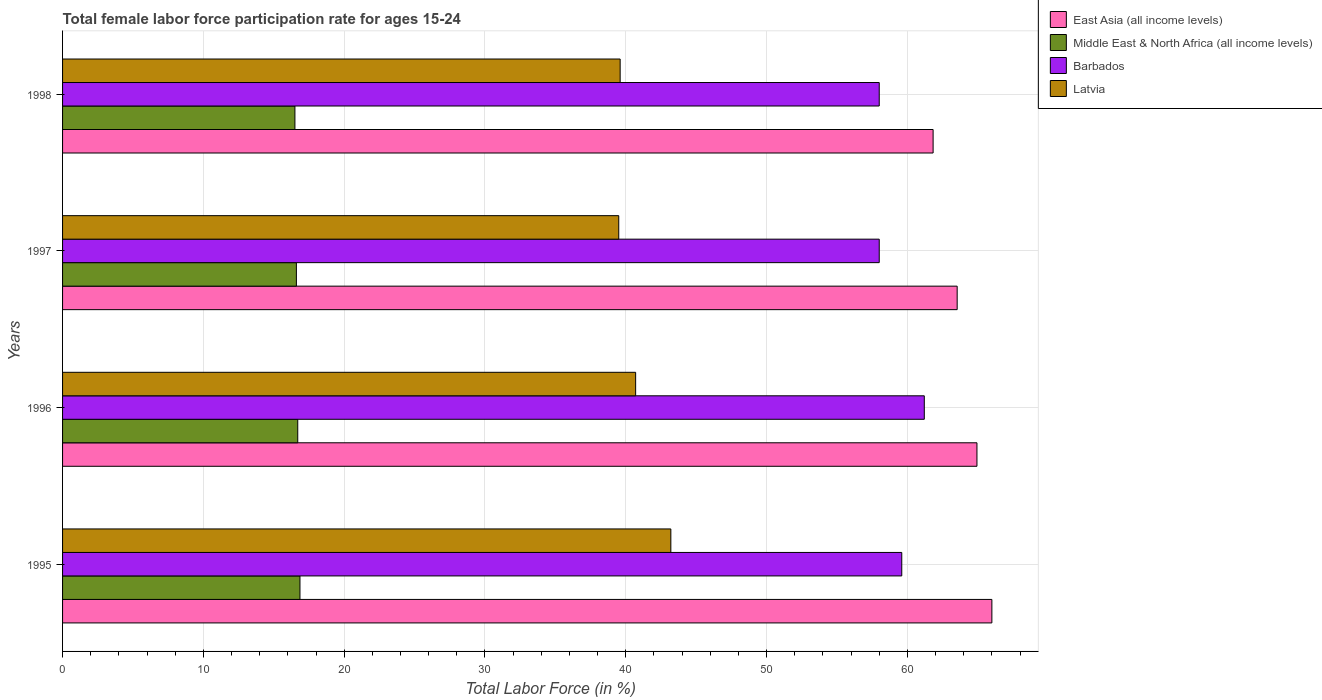How many different coloured bars are there?
Your response must be concise. 4. How many bars are there on the 1st tick from the top?
Provide a succinct answer. 4. What is the label of the 1st group of bars from the top?
Provide a succinct answer. 1998. In how many cases, is the number of bars for a given year not equal to the number of legend labels?
Your answer should be compact. 0. What is the female labor force participation rate in Middle East & North Africa (all income levels) in 1997?
Provide a succinct answer. 16.61. Across all years, what is the maximum female labor force participation rate in East Asia (all income levels)?
Keep it short and to the point. 66. Across all years, what is the minimum female labor force participation rate in Middle East & North Africa (all income levels)?
Provide a succinct answer. 16.5. In which year was the female labor force participation rate in Middle East & North Africa (all income levels) maximum?
Provide a short and direct response. 1995. What is the total female labor force participation rate in East Asia (all income levels) in the graph?
Give a very brief answer. 256.3. What is the difference between the female labor force participation rate in Middle East & North Africa (all income levels) in 1995 and that in 1997?
Ensure brevity in your answer.  0.25. What is the difference between the female labor force participation rate in Latvia in 1996 and the female labor force participation rate in Barbados in 1998?
Provide a short and direct response. -17.3. What is the average female labor force participation rate in East Asia (all income levels) per year?
Your answer should be compact. 64.07. In the year 1995, what is the difference between the female labor force participation rate in Middle East & North Africa (all income levels) and female labor force participation rate in Barbados?
Offer a very short reply. -42.74. What is the ratio of the female labor force participation rate in Latvia in 1996 to that in 1997?
Keep it short and to the point. 1.03. Is the difference between the female labor force participation rate in Middle East & North Africa (all income levels) in 1996 and 1997 greater than the difference between the female labor force participation rate in Barbados in 1996 and 1997?
Your response must be concise. No. What is the difference between the highest and the second highest female labor force participation rate in Middle East & North Africa (all income levels)?
Your answer should be very brief. 0.16. What is the difference between the highest and the lowest female labor force participation rate in Latvia?
Keep it short and to the point. 3.7. In how many years, is the female labor force participation rate in Middle East & North Africa (all income levels) greater than the average female labor force participation rate in Middle East & North Africa (all income levels) taken over all years?
Your response must be concise. 2. Is the sum of the female labor force participation rate in Latvia in 1995 and 1996 greater than the maximum female labor force participation rate in East Asia (all income levels) across all years?
Your response must be concise. Yes. Is it the case that in every year, the sum of the female labor force participation rate in Barbados and female labor force participation rate in Middle East & North Africa (all income levels) is greater than the sum of female labor force participation rate in East Asia (all income levels) and female labor force participation rate in Latvia?
Your response must be concise. No. What does the 1st bar from the top in 1997 represents?
Your answer should be compact. Latvia. What does the 2nd bar from the bottom in 1996 represents?
Offer a terse response. Middle East & North Africa (all income levels). Is it the case that in every year, the sum of the female labor force participation rate in Latvia and female labor force participation rate in East Asia (all income levels) is greater than the female labor force participation rate in Barbados?
Ensure brevity in your answer.  Yes. How many years are there in the graph?
Keep it short and to the point. 4. Are the values on the major ticks of X-axis written in scientific E-notation?
Keep it short and to the point. No. Where does the legend appear in the graph?
Your answer should be compact. Top right. What is the title of the graph?
Give a very brief answer. Total female labor force participation rate for ages 15-24. Does "El Salvador" appear as one of the legend labels in the graph?
Keep it short and to the point. No. What is the label or title of the X-axis?
Offer a very short reply. Total Labor Force (in %). What is the Total Labor Force (in %) of East Asia (all income levels) in 1995?
Your answer should be compact. 66. What is the Total Labor Force (in %) in Middle East & North Africa (all income levels) in 1995?
Your answer should be very brief. 16.86. What is the Total Labor Force (in %) of Barbados in 1995?
Your answer should be very brief. 59.6. What is the Total Labor Force (in %) of Latvia in 1995?
Your answer should be very brief. 43.2. What is the Total Labor Force (in %) of East Asia (all income levels) in 1996?
Offer a terse response. 64.94. What is the Total Labor Force (in %) in Middle East & North Africa (all income levels) in 1996?
Provide a succinct answer. 16.7. What is the Total Labor Force (in %) in Barbados in 1996?
Your answer should be compact. 61.2. What is the Total Labor Force (in %) in Latvia in 1996?
Provide a short and direct response. 40.7. What is the Total Labor Force (in %) of East Asia (all income levels) in 1997?
Your answer should be compact. 63.53. What is the Total Labor Force (in %) of Middle East & North Africa (all income levels) in 1997?
Give a very brief answer. 16.61. What is the Total Labor Force (in %) of Latvia in 1997?
Provide a succinct answer. 39.5. What is the Total Labor Force (in %) in East Asia (all income levels) in 1998?
Offer a terse response. 61.83. What is the Total Labor Force (in %) of Middle East & North Africa (all income levels) in 1998?
Ensure brevity in your answer.  16.5. What is the Total Labor Force (in %) of Barbados in 1998?
Offer a very short reply. 58. What is the Total Labor Force (in %) in Latvia in 1998?
Give a very brief answer. 39.6. Across all years, what is the maximum Total Labor Force (in %) of East Asia (all income levels)?
Ensure brevity in your answer.  66. Across all years, what is the maximum Total Labor Force (in %) in Middle East & North Africa (all income levels)?
Ensure brevity in your answer.  16.86. Across all years, what is the maximum Total Labor Force (in %) in Barbados?
Keep it short and to the point. 61.2. Across all years, what is the maximum Total Labor Force (in %) of Latvia?
Provide a short and direct response. 43.2. Across all years, what is the minimum Total Labor Force (in %) of East Asia (all income levels)?
Your answer should be very brief. 61.83. Across all years, what is the minimum Total Labor Force (in %) of Middle East & North Africa (all income levels)?
Provide a succinct answer. 16.5. Across all years, what is the minimum Total Labor Force (in %) of Latvia?
Your response must be concise. 39.5. What is the total Total Labor Force (in %) of East Asia (all income levels) in the graph?
Offer a terse response. 256.3. What is the total Total Labor Force (in %) in Middle East & North Africa (all income levels) in the graph?
Offer a very short reply. 66.67. What is the total Total Labor Force (in %) of Barbados in the graph?
Provide a succinct answer. 236.8. What is the total Total Labor Force (in %) in Latvia in the graph?
Your answer should be very brief. 163. What is the difference between the Total Labor Force (in %) of East Asia (all income levels) in 1995 and that in 1996?
Make the answer very short. 1.06. What is the difference between the Total Labor Force (in %) in Middle East & North Africa (all income levels) in 1995 and that in 1996?
Offer a very short reply. 0.16. What is the difference between the Total Labor Force (in %) of Barbados in 1995 and that in 1996?
Provide a short and direct response. -1.6. What is the difference between the Total Labor Force (in %) in Latvia in 1995 and that in 1996?
Offer a very short reply. 2.5. What is the difference between the Total Labor Force (in %) in East Asia (all income levels) in 1995 and that in 1997?
Make the answer very short. 2.46. What is the difference between the Total Labor Force (in %) in Middle East & North Africa (all income levels) in 1995 and that in 1997?
Ensure brevity in your answer.  0.25. What is the difference between the Total Labor Force (in %) in Barbados in 1995 and that in 1997?
Keep it short and to the point. 1.6. What is the difference between the Total Labor Force (in %) in Latvia in 1995 and that in 1997?
Provide a succinct answer. 3.7. What is the difference between the Total Labor Force (in %) in East Asia (all income levels) in 1995 and that in 1998?
Ensure brevity in your answer.  4.17. What is the difference between the Total Labor Force (in %) of Middle East & North Africa (all income levels) in 1995 and that in 1998?
Provide a short and direct response. 0.36. What is the difference between the Total Labor Force (in %) in Barbados in 1995 and that in 1998?
Offer a terse response. 1.6. What is the difference between the Total Labor Force (in %) of Latvia in 1995 and that in 1998?
Your response must be concise. 3.6. What is the difference between the Total Labor Force (in %) of East Asia (all income levels) in 1996 and that in 1997?
Keep it short and to the point. 1.41. What is the difference between the Total Labor Force (in %) in Middle East & North Africa (all income levels) in 1996 and that in 1997?
Ensure brevity in your answer.  0.1. What is the difference between the Total Labor Force (in %) of Barbados in 1996 and that in 1997?
Provide a succinct answer. 3.2. What is the difference between the Total Labor Force (in %) of Latvia in 1996 and that in 1997?
Your answer should be very brief. 1.2. What is the difference between the Total Labor Force (in %) in East Asia (all income levels) in 1996 and that in 1998?
Offer a terse response. 3.11. What is the difference between the Total Labor Force (in %) in Middle East & North Africa (all income levels) in 1996 and that in 1998?
Provide a succinct answer. 0.2. What is the difference between the Total Labor Force (in %) of Barbados in 1996 and that in 1998?
Offer a very short reply. 3.2. What is the difference between the Total Labor Force (in %) of Latvia in 1996 and that in 1998?
Offer a very short reply. 1.1. What is the difference between the Total Labor Force (in %) of East Asia (all income levels) in 1997 and that in 1998?
Your answer should be compact. 1.71. What is the difference between the Total Labor Force (in %) of Middle East & North Africa (all income levels) in 1997 and that in 1998?
Make the answer very short. 0.1. What is the difference between the Total Labor Force (in %) of Latvia in 1997 and that in 1998?
Your answer should be compact. -0.1. What is the difference between the Total Labor Force (in %) of East Asia (all income levels) in 1995 and the Total Labor Force (in %) of Middle East & North Africa (all income levels) in 1996?
Your answer should be very brief. 49.3. What is the difference between the Total Labor Force (in %) of East Asia (all income levels) in 1995 and the Total Labor Force (in %) of Barbados in 1996?
Your answer should be compact. 4.8. What is the difference between the Total Labor Force (in %) in East Asia (all income levels) in 1995 and the Total Labor Force (in %) in Latvia in 1996?
Your response must be concise. 25.3. What is the difference between the Total Labor Force (in %) of Middle East & North Africa (all income levels) in 1995 and the Total Labor Force (in %) of Barbados in 1996?
Make the answer very short. -44.34. What is the difference between the Total Labor Force (in %) in Middle East & North Africa (all income levels) in 1995 and the Total Labor Force (in %) in Latvia in 1996?
Give a very brief answer. -23.84. What is the difference between the Total Labor Force (in %) of Barbados in 1995 and the Total Labor Force (in %) of Latvia in 1996?
Your response must be concise. 18.9. What is the difference between the Total Labor Force (in %) of East Asia (all income levels) in 1995 and the Total Labor Force (in %) of Middle East & North Africa (all income levels) in 1997?
Keep it short and to the point. 49.39. What is the difference between the Total Labor Force (in %) in East Asia (all income levels) in 1995 and the Total Labor Force (in %) in Barbados in 1997?
Your answer should be very brief. 8. What is the difference between the Total Labor Force (in %) in East Asia (all income levels) in 1995 and the Total Labor Force (in %) in Latvia in 1997?
Provide a succinct answer. 26.5. What is the difference between the Total Labor Force (in %) of Middle East & North Africa (all income levels) in 1995 and the Total Labor Force (in %) of Barbados in 1997?
Provide a succinct answer. -41.14. What is the difference between the Total Labor Force (in %) of Middle East & North Africa (all income levels) in 1995 and the Total Labor Force (in %) of Latvia in 1997?
Keep it short and to the point. -22.64. What is the difference between the Total Labor Force (in %) in Barbados in 1995 and the Total Labor Force (in %) in Latvia in 1997?
Keep it short and to the point. 20.1. What is the difference between the Total Labor Force (in %) in East Asia (all income levels) in 1995 and the Total Labor Force (in %) in Middle East & North Africa (all income levels) in 1998?
Your answer should be very brief. 49.5. What is the difference between the Total Labor Force (in %) of East Asia (all income levels) in 1995 and the Total Labor Force (in %) of Barbados in 1998?
Provide a short and direct response. 8. What is the difference between the Total Labor Force (in %) in East Asia (all income levels) in 1995 and the Total Labor Force (in %) in Latvia in 1998?
Keep it short and to the point. 26.4. What is the difference between the Total Labor Force (in %) of Middle East & North Africa (all income levels) in 1995 and the Total Labor Force (in %) of Barbados in 1998?
Provide a short and direct response. -41.14. What is the difference between the Total Labor Force (in %) in Middle East & North Africa (all income levels) in 1995 and the Total Labor Force (in %) in Latvia in 1998?
Offer a terse response. -22.74. What is the difference between the Total Labor Force (in %) in Barbados in 1995 and the Total Labor Force (in %) in Latvia in 1998?
Give a very brief answer. 20. What is the difference between the Total Labor Force (in %) of East Asia (all income levels) in 1996 and the Total Labor Force (in %) of Middle East & North Africa (all income levels) in 1997?
Make the answer very short. 48.33. What is the difference between the Total Labor Force (in %) of East Asia (all income levels) in 1996 and the Total Labor Force (in %) of Barbados in 1997?
Your response must be concise. 6.94. What is the difference between the Total Labor Force (in %) in East Asia (all income levels) in 1996 and the Total Labor Force (in %) in Latvia in 1997?
Keep it short and to the point. 25.44. What is the difference between the Total Labor Force (in %) of Middle East & North Africa (all income levels) in 1996 and the Total Labor Force (in %) of Barbados in 1997?
Offer a terse response. -41.3. What is the difference between the Total Labor Force (in %) of Middle East & North Africa (all income levels) in 1996 and the Total Labor Force (in %) of Latvia in 1997?
Your response must be concise. -22.8. What is the difference between the Total Labor Force (in %) in Barbados in 1996 and the Total Labor Force (in %) in Latvia in 1997?
Provide a succinct answer. 21.7. What is the difference between the Total Labor Force (in %) in East Asia (all income levels) in 1996 and the Total Labor Force (in %) in Middle East & North Africa (all income levels) in 1998?
Keep it short and to the point. 48.44. What is the difference between the Total Labor Force (in %) of East Asia (all income levels) in 1996 and the Total Labor Force (in %) of Barbados in 1998?
Make the answer very short. 6.94. What is the difference between the Total Labor Force (in %) of East Asia (all income levels) in 1996 and the Total Labor Force (in %) of Latvia in 1998?
Offer a very short reply. 25.34. What is the difference between the Total Labor Force (in %) in Middle East & North Africa (all income levels) in 1996 and the Total Labor Force (in %) in Barbados in 1998?
Your answer should be compact. -41.3. What is the difference between the Total Labor Force (in %) in Middle East & North Africa (all income levels) in 1996 and the Total Labor Force (in %) in Latvia in 1998?
Provide a short and direct response. -22.9. What is the difference between the Total Labor Force (in %) in Barbados in 1996 and the Total Labor Force (in %) in Latvia in 1998?
Give a very brief answer. 21.6. What is the difference between the Total Labor Force (in %) of East Asia (all income levels) in 1997 and the Total Labor Force (in %) of Middle East & North Africa (all income levels) in 1998?
Give a very brief answer. 47.03. What is the difference between the Total Labor Force (in %) in East Asia (all income levels) in 1997 and the Total Labor Force (in %) in Barbados in 1998?
Offer a terse response. 5.53. What is the difference between the Total Labor Force (in %) in East Asia (all income levels) in 1997 and the Total Labor Force (in %) in Latvia in 1998?
Your answer should be very brief. 23.93. What is the difference between the Total Labor Force (in %) of Middle East & North Africa (all income levels) in 1997 and the Total Labor Force (in %) of Barbados in 1998?
Offer a very short reply. -41.39. What is the difference between the Total Labor Force (in %) of Middle East & North Africa (all income levels) in 1997 and the Total Labor Force (in %) of Latvia in 1998?
Keep it short and to the point. -22.99. What is the difference between the Total Labor Force (in %) in Barbados in 1997 and the Total Labor Force (in %) in Latvia in 1998?
Offer a terse response. 18.4. What is the average Total Labor Force (in %) of East Asia (all income levels) per year?
Provide a succinct answer. 64.08. What is the average Total Labor Force (in %) in Middle East & North Africa (all income levels) per year?
Offer a terse response. 16.67. What is the average Total Labor Force (in %) of Barbados per year?
Give a very brief answer. 59.2. What is the average Total Labor Force (in %) of Latvia per year?
Your answer should be compact. 40.75. In the year 1995, what is the difference between the Total Labor Force (in %) of East Asia (all income levels) and Total Labor Force (in %) of Middle East & North Africa (all income levels)?
Your answer should be compact. 49.14. In the year 1995, what is the difference between the Total Labor Force (in %) in East Asia (all income levels) and Total Labor Force (in %) in Barbados?
Provide a succinct answer. 6.4. In the year 1995, what is the difference between the Total Labor Force (in %) in East Asia (all income levels) and Total Labor Force (in %) in Latvia?
Provide a short and direct response. 22.8. In the year 1995, what is the difference between the Total Labor Force (in %) in Middle East & North Africa (all income levels) and Total Labor Force (in %) in Barbados?
Ensure brevity in your answer.  -42.74. In the year 1995, what is the difference between the Total Labor Force (in %) in Middle East & North Africa (all income levels) and Total Labor Force (in %) in Latvia?
Ensure brevity in your answer.  -26.34. In the year 1996, what is the difference between the Total Labor Force (in %) of East Asia (all income levels) and Total Labor Force (in %) of Middle East & North Africa (all income levels)?
Keep it short and to the point. 48.24. In the year 1996, what is the difference between the Total Labor Force (in %) of East Asia (all income levels) and Total Labor Force (in %) of Barbados?
Offer a terse response. 3.74. In the year 1996, what is the difference between the Total Labor Force (in %) of East Asia (all income levels) and Total Labor Force (in %) of Latvia?
Provide a succinct answer. 24.24. In the year 1996, what is the difference between the Total Labor Force (in %) of Middle East & North Africa (all income levels) and Total Labor Force (in %) of Barbados?
Your response must be concise. -44.5. In the year 1996, what is the difference between the Total Labor Force (in %) in Middle East & North Africa (all income levels) and Total Labor Force (in %) in Latvia?
Offer a very short reply. -24. In the year 1997, what is the difference between the Total Labor Force (in %) in East Asia (all income levels) and Total Labor Force (in %) in Middle East & North Africa (all income levels)?
Give a very brief answer. 46.93. In the year 1997, what is the difference between the Total Labor Force (in %) in East Asia (all income levels) and Total Labor Force (in %) in Barbados?
Keep it short and to the point. 5.53. In the year 1997, what is the difference between the Total Labor Force (in %) of East Asia (all income levels) and Total Labor Force (in %) of Latvia?
Keep it short and to the point. 24.03. In the year 1997, what is the difference between the Total Labor Force (in %) in Middle East & North Africa (all income levels) and Total Labor Force (in %) in Barbados?
Offer a terse response. -41.39. In the year 1997, what is the difference between the Total Labor Force (in %) of Middle East & North Africa (all income levels) and Total Labor Force (in %) of Latvia?
Give a very brief answer. -22.89. In the year 1997, what is the difference between the Total Labor Force (in %) in Barbados and Total Labor Force (in %) in Latvia?
Your answer should be very brief. 18.5. In the year 1998, what is the difference between the Total Labor Force (in %) of East Asia (all income levels) and Total Labor Force (in %) of Middle East & North Africa (all income levels)?
Give a very brief answer. 45.32. In the year 1998, what is the difference between the Total Labor Force (in %) of East Asia (all income levels) and Total Labor Force (in %) of Barbados?
Offer a very short reply. 3.83. In the year 1998, what is the difference between the Total Labor Force (in %) of East Asia (all income levels) and Total Labor Force (in %) of Latvia?
Give a very brief answer. 22.23. In the year 1998, what is the difference between the Total Labor Force (in %) of Middle East & North Africa (all income levels) and Total Labor Force (in %) of Barbados?
Your answer should be very brief. -41.5. In the year 1998, what is the difference between the Total Labor Force (in %) in Middle East & North Africa (all income levels) and Total Labor Force (in %) in Latvia?
Provide a succinct answer. -23.1. What is the ratio of the Total Labor Force (in %) of East Asia (all income levels) in 1995 to that in 1996?
Your answer should be very brief. 1.02. What is the ratio of the Total Labor Force (in %) of Middle East & North Africa (all income levels) in 1995 to that in 1996?
Your answer should be very brief. 1.01. What is the ratio of the Total Labor Force (in %) of Barbados in 1995 to that in 1996?
Make the answer very short. 0.97. What is the ratio of the Total Labor Force (in %) in Latvia in 1995 to that in 1996?
Offer a terse response. 1.06. What is the ratio of the Total Labor Force (in %) of East Asia (all income levels) in 1995 to that in 1997?
Offer a terse response. 1.04. What is the ratio of the Total Labor Force (in %) of Middle East & North Africa (all income levels) in 1995 to that in 1997?
Keep it short and to the point. 1.02. What is the ratio of the Total Labor Force (in %) of Barbados in 1995 to that in 1997?
Provide a succinct answer. 1.03. What is the ratio of the Total Labor Force (in %) in Latvia in 1995 to that in 1997?
Your answer should be very brief. 1.09. What is the ratio of the Total Labor Force (in %) of East Asia (all income levels) in 1995 to that in 1998?
Offer a very short reply. 1.07. What is the ratio of the Total Labor Force (in %) of Middle East & North Africa (all income levels) in 1995 to that in 1998?
Provide a succinct answer. 1.02. What is the ratio of the Total Labor Force (in %) of Barbados in 1995 to that in 1998?
Your response must be concise. 1.03. What is the ratio of the Total Labor Force (in %) in Latvia in 1995 to that in 1998?
Provide a short and direct response. 1.09. What is the ratio of the Total Labor Force (in %) in East Asia (all income levels) in 1996 to that in 1997?
Provide a succinct answer. 1.02. What is the ratio of the Total Labor Force (in %) of Middle East & North Africa (all income levels) in 1996 to that in 1997?
Offer a very short reply. 1.01. What is the ratio of the Total Labor Force (in %) in Barbados in 1996 to that in 1997?
Provide a succinct answer. 1.06. What is the ratio of the Total Labor Force (in %) of Latvia in 1996 to that in 1997?
Your answer should be very brief. 1.03. What is the ratio of the Total Labor Force (in %) of East Asia (all income levels) in 1996 to that in 1998?
Provide a succinct answer. 1.05. What is the ratio of the Total Labor Force (in %) of Middle East & North Africa (all income levels) in 1996 to that in 1998?
Make the answer very short. 1.01. What is the ratio of the Total Labor Force (in %) in Barbados in 1996 to that in 1998?
Your answer should be compact. 1.06. What is the ratio of the Total Labor Force (in %) of Latvia in 1996 to that in 1998?
Provide a succinct answer. 1.03. What is the ratio of the Total Labor Force (in %) of East Asia (all income levels) in 1997 to that in 1998?
Make the answer very short. 1.03. What is the ratio of the Total Labor Force (in %) in Latvia in 1997 to that in 1998?
Provide a short and direct response. 1. What is the difference between the highest and the second highest Total Labor Force (in %) of East Asia (all income levels)?
Provide a succinct answer. 1.06. What is the difference between the highest and the second highest Total Labor Force (in %) of Middle East & North Africa (all income levels)?
Give a very brief answer. 0.16. What is the difference between the highest and the second highest Total Labor Force (in %) in Barbados?
Offer a very short reply. 1.6. What is the difference between the highest and the second highest Total Labor Force (in %) in Latvia?
Make the answer very short. 2.5. What is the difference between the highest and the lowest Total Labor Force (in %) in East Asia (all income levels)?
Give a very brief answer. 4.17. What is the difference between the highest and the lowest Total Labor Force (in %) in Middle East & North Africa (all income levels)?
Provide a succinct answer. 0.36. What is the difference between the highest and the lowest Total Labor Force (in %) in Barbados?
Provide a succinct answer. 3.2. What is the difference between the highest and the lowest Total Labor Force (in %) in Latvia?
Your response must be concise. 3.7. 